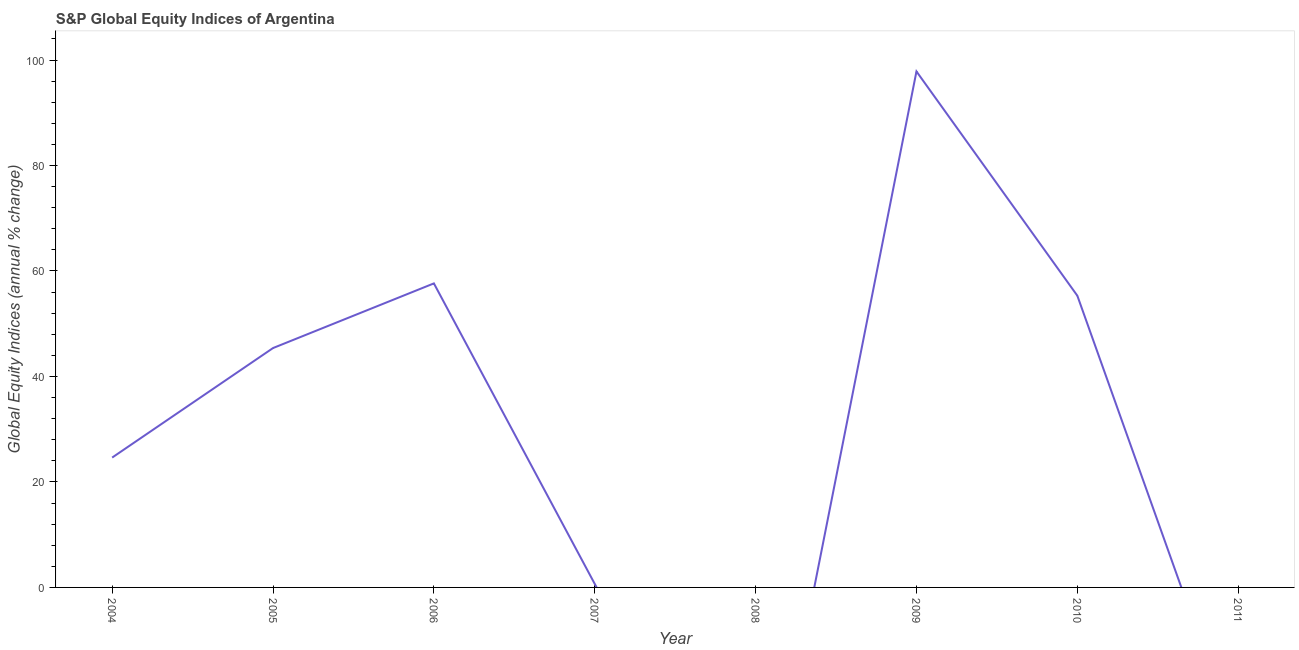Across all years, what is the maximum s&p global equity indices?
Your response must be concise. 97.84. In which year was the s&p global equity indices maximum?
Give a very brief answer. 2009. What is the sum of the s&p global equity indices?
Give a very brief answer. 281.48. What is the difference between the s&p global equity indices in 2009 and 2010?
Your answer should be very brief. 42.52. What is the average s&p global equity indices per year?
Your answer should be very brief. 35.19. What is the median s&p global equity indices?
Give a very brief answer. 35. What is the ratio of the s&p global equity indices in 2004 to that in 2007?
Ensure brevity in your answer.  36.8. What is the difference between the highest and the second highest s&p global equity indices?
Make the answer very short. 40.19. Is the sum of the s&p global equity indices in 2005 and 2010 greater than the maximum s&p global equity indices across all years?
Provide a succinct answer. Yes. What is the difference between the highest and the lowest s&p global equity indices?
Ensure brevity in your answer.  97.84. In how many years, is the s&p global equity indices greater than the average s&p global equity indices taken over all years?
Your answer should be compact. 4. What is the title of the graph?
Offer a terse response. S&P Global Equity Indices of Argentina. What is the label or title of the X-axis?
Keep it short and to the point. Year. What is the label or title of the Y-axis?
Your answer should be compact. Global Equity Indices (annual % change). What is the Global Equity Indices (annual % change) in 2004?
Provide a succinct answer. 24.62. What is the Global Equity Indices (annual % change) in 2005?
Offer a terse response. 45.39. What is the Global Equity Indices (annual % change) of 2006?
Make the answer very short. 57.65. What is the Global Equity Indices (annual % change) in 2007?
Your response must be concise. 0.67. What is the Global Equity Indices (annual % change) of 2008?
Your answer should be very brief. 0. What is the Global Equity Indices (annual % change) in 2009?
Your response must be concise. 97.84. What is the Global Equity Indices (annual % change) in 2010?
Offer a very short reply. 55.32. What is the difference between the Global Equity Indices (annual % change) in 2004 and 2005?
Your answer should be very brief. -20.77. What is the difference between the Global Equity Indices (annual % change) in 2004 and 2006?
Ensure brevity in your answer.  -33.03. What is the difference between the Global Equity Indices (annual % change) in 2004 and 2007?
Provide a short and direct response. 23.95. What is the difference between the Global Equity Indices (annual % change) in 2004 and 2009?
Offer a terse response. -73.22. What is the difference between the Global Equity Indices (annual % change) in 2004 and 2010?
Offer a very short reply. -30.7. What is the difference between the Global Equity Indices (annual % change) in 2005 and 2006?
Your answer should be compact. -12.26. What is the difference between the Global Equity Indices (annual % change) in 2005 and 2007?
Ensure brevity in your answer.  44.72. What is the difference between the Global Equity Indices (annual % change) in 2005 and 2009?
Ensure brevity in your answer.  -52.45. What is the difference between the Global Equity Indices (annual % change) in 2005 and 2010?
Your answer should be very brief. -9.93. What is the difference between the Global Equity Indices (annual % change) in 2006 and 2007?
Offer a terse response. 56.98. What is the difference between the Global Equity Indices (annual % change) in 2006 and 2009?
Offer a very short reply. -40.19. What is the difference between the Global Equity Indices (annual % change) in 2006 and 2010?
Your answer should be compact. 2.33. What is the difference between the Global Equity Indices (annual % change) in 2007 and 2009?
Ensure brevity in your answer.  -97.17. What is the difference between the Global Equity Indices (annual % change) in 2007 and 2010?
Your answer should be compact. -54.65. What is the difference between the Global Equity Indices (annual % change) in 2009 and 2010?
Ensure brevity in your answer.  42.52. What is the ratio of the Global Equity Indices (annual % change) in 2004 to that in 2005?
Give a very brief answer. 0.54. What is the ratio of the Global Equity Indices (annual % change) in 2004 to that in 2006?
Offer a terse response. 0.43. What is the ratio of the Global Equity Indices (annual % change) in 2004 to that in 2007?
Offer a very short reply. 36.8. What is the ratio of the Global Equity Indices (annual % change) in 2004 to that in 2009?
Make the answer very short. 0.25. What is the ratio of the Global Equity Indices (annual % change) in 2004 to that in 2010?
Your answer should be compact. 0.45. What is the ratio of the Global Equity Indices (annual % change) in 2005 to that in 2006?
Your response must be concise. 0.79. What is the ratio of the Global Equity Indices (annual % change) in 2005 to that in 2007?
Provide a short and direct response. 67.84. What is the ratio of the Global Equity Indices (annual % change) in 2005 to that in 2009?
Provide a short and direct response. 0.46. What is the ratio of the Global Equity Indices (annual % change) in 2005 to that in 2010?
Ensure brevity in your answer.  0.82. What is the ratio of the Global Equity Indices (annual % change) in 2006 to that in 2007?
Your response must be concise. 86.17. What is the ratio of the Global Equity Indices (annual % change) in 2006 to that in 2009?
Give a very brief answer. 0.59. What is the ratio of the Global Equity Indices (annual % change) in 2006 to that in 2010?
Offer a very short reply. 1.04. What is the ratio of the Global Equity Indices (annual % change) in 2007 to that in 2009?
Your response must be concise. 0.01. What is the ratio of the Global Equity Indices (annual % change) in 2007 to that in 2010?
Your response must be concise. 0.01. What is the ratio of the Global Equity Indices (annual % change) in 2009 to that in 2010?
Keep it short and to the point. 1.77. 